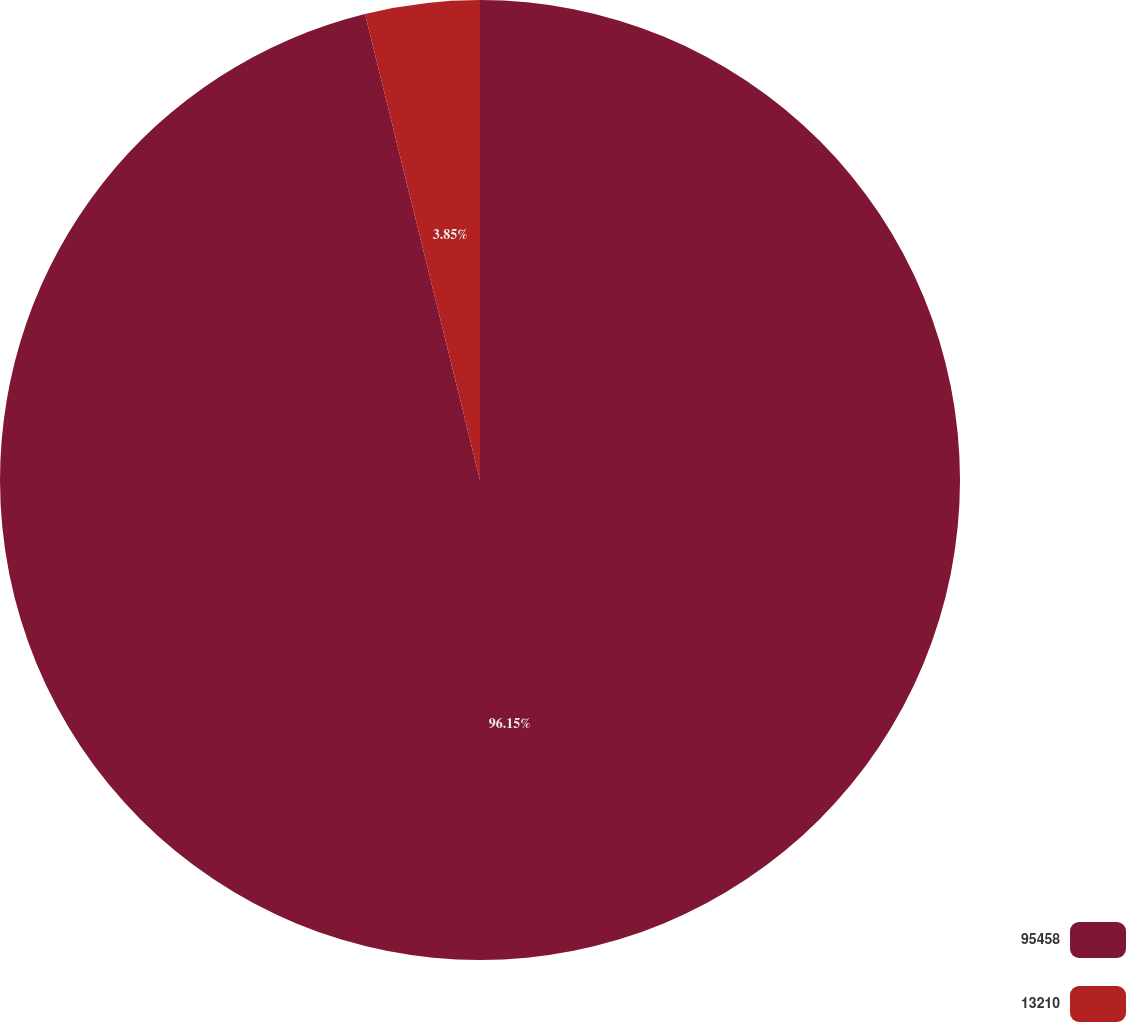<chart> <loc_0><loc_0><loc_500><loc_500><pie_chart><fcel>95458<fcel>13210<nl><fcel>96.15%<fcel>3.85%<nl></chart> 